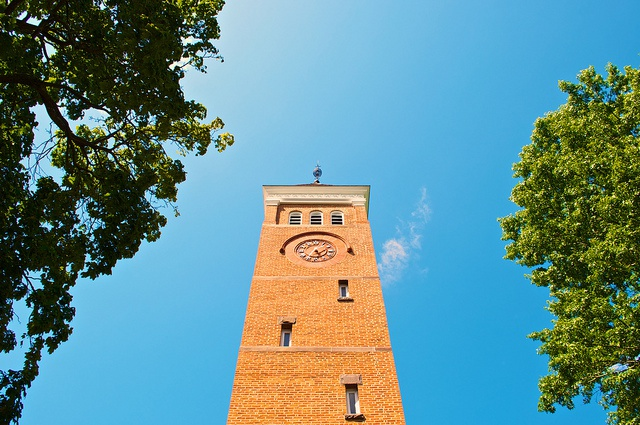Describe the objects in this image and their specific colors. I can see a clock in green, tan, and brown tones in this image. 